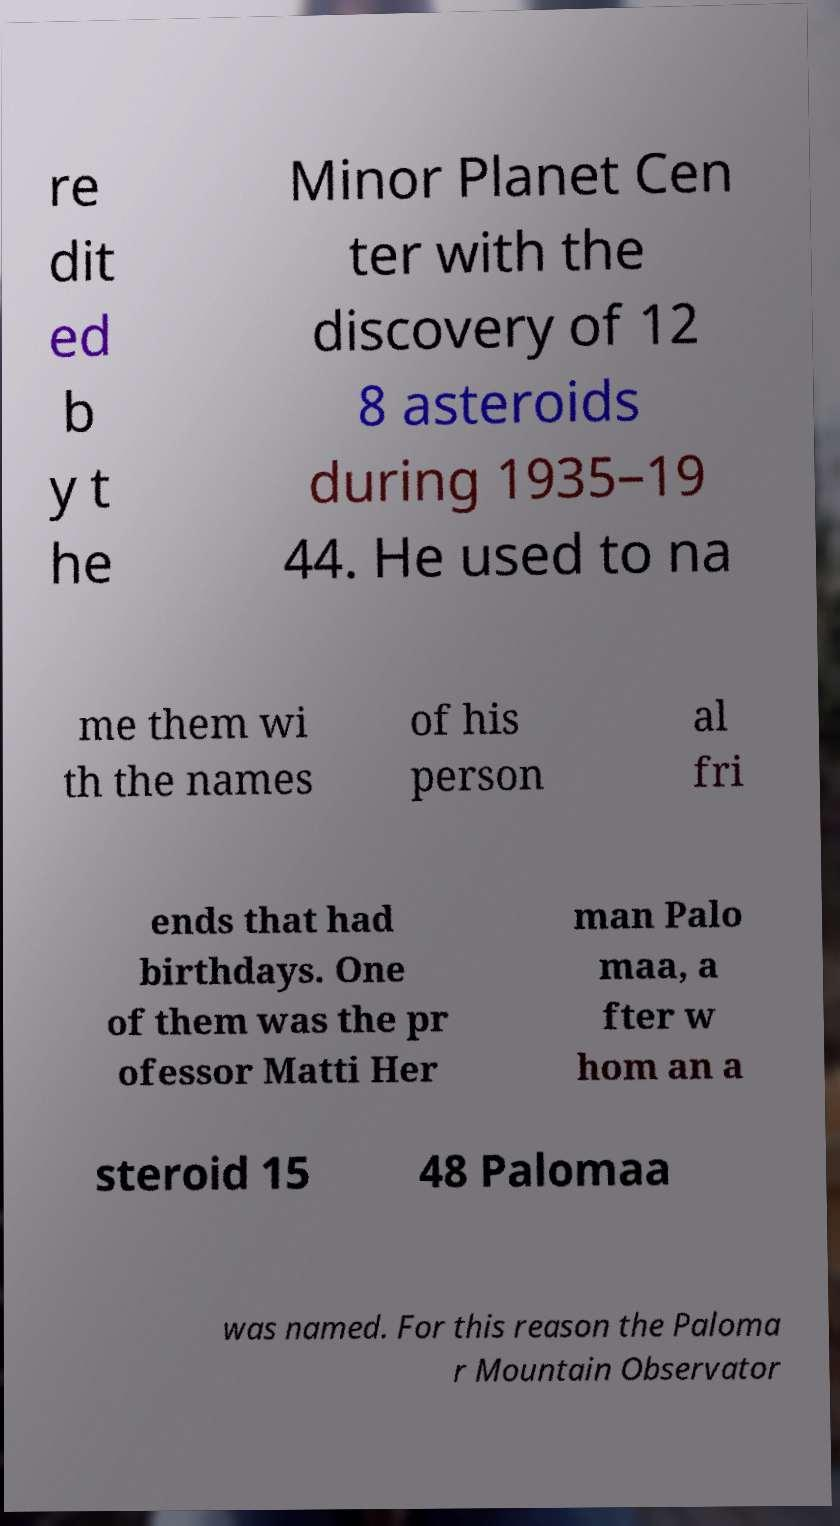What messages or text are displayed in this image? I need them in a readable, typed format. re dit ed b y t he Minor Planet Cen ter with the discovery of 12 8 asteroids during 1935–19 44. He used to na me them wi th the names of his person al fri ends that had birthdays. One of them was the pr ofessor Matti Her man Palo maa, a fter w hom an a steroid 15 48 Palomaa was named. For this reason the Paloma r Mountain Observator 